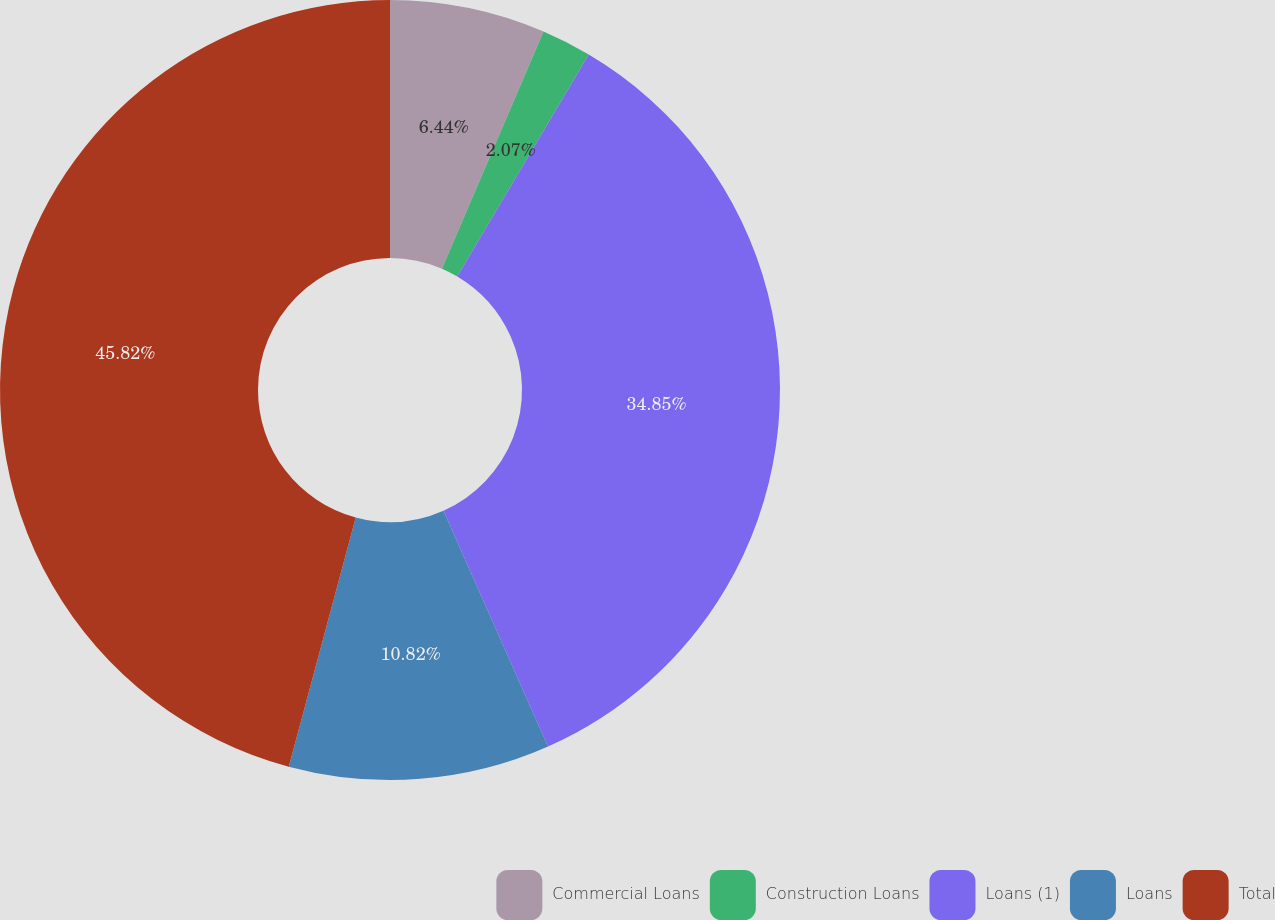Convert chart. <chart><loc_0><loc_0><loc_500><loc_500><pie_chart><fcel>Commercial Loans<fcel>Construction Loans<fcel>Loans (1)<fcel>Loans<fcel>Total<nl><fcel>6.44%<fcel>2.07%<fcel>34.85%<fcel>10.82%<fcel>45.82%<nl></chart> 